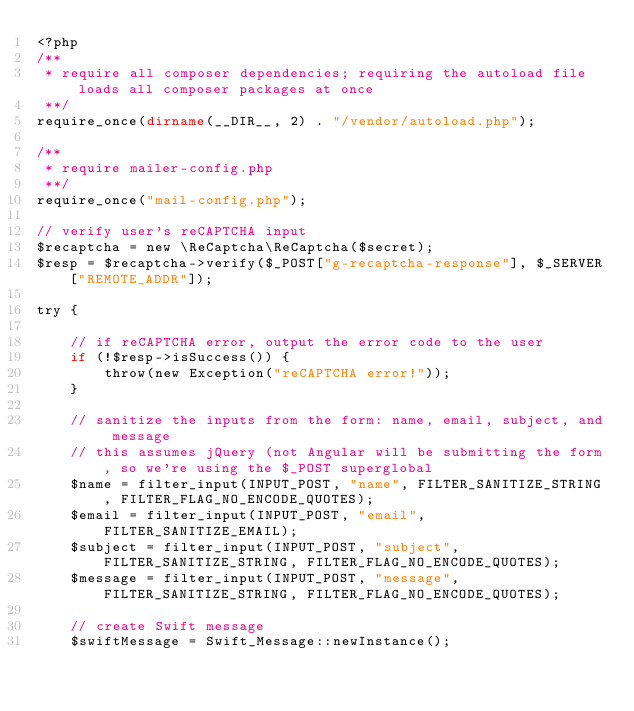<code> <loc_0><loc_0><loc_500><loc_500><_PHP_><?php
/**
 * require all composer dependencies; requiring the autoload file loads all composer packages at once
 **/
require_once(dirname(__DIR__, 2) . "/vendor/autoload.php");

/**
 * require mailer-config.php
 **/
require_once("mail-config.php");

// verify user's reCAPTCHA input
$recaptcha = new \ReCaptcha\ReCaptcha($secret);
$resp = $recaptcha->verify($_POST["g-recaptcha-response"], $_SERVER["REMOTE_ADDR"]);

try {

	// if reCAPTCHA error, output the error code to the user
	if (!$resp->isSuccess()) {
		throw(new Exception("reCAPTCHA error!"));
	}

	// sanitize the inputs from the form: name, email, subject, and message
	// this assumes jQuery (not Angular will be submitting the form, so we're using the $_POST superglobal
	$name = filter_input(INPUT_POST, "name", FILTER_SANITIZE_STRING, FILTER_FLAG_NO_ENCODE_QUOTES);
	$email = filter_input(INPUT_POST, "email", FILTER_SANITIZE_EMAIL);
	$subject = filter_input(INPUT_POST, "subject", FILTER_SANITIZE_STRING, FILTER_FLAG_NO_ENCODE_QUOTES);
	$message = filter_input(INPUT_POST, "message", FILTER_SANITIZE_STRING, FILTER_FLAG_NO_ENCODE_QUOTES);

	// create Swift message
	$swiftMessage = Swift_Message::newInstance();
</code> 